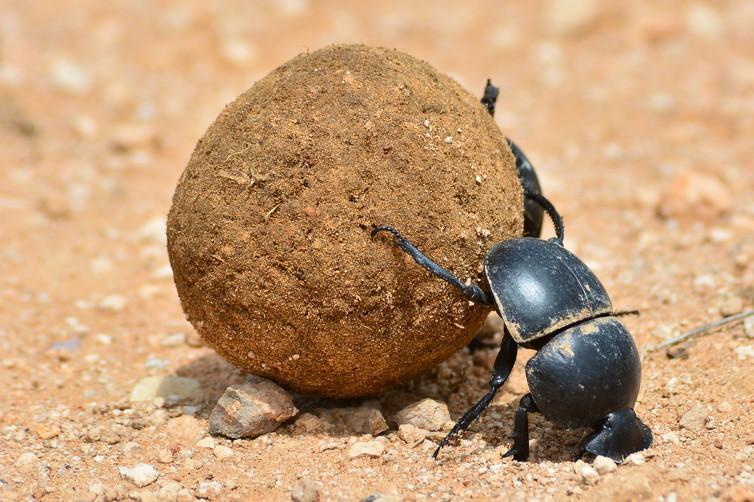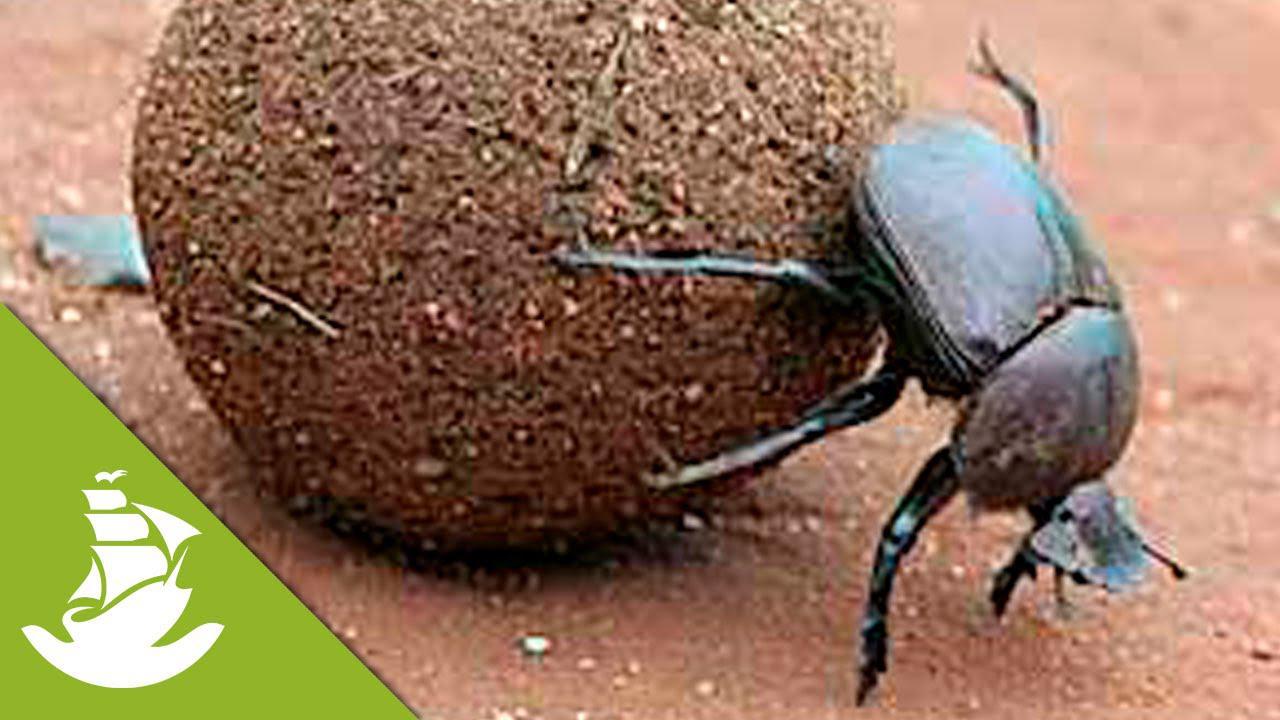The first image is the image on the left, the second image is the image on the right. Analyze the images presented: Is the assertion "Both images show beetles on dung balls with their bodies in the same general pose and location." valid? Answer yes or no. Yes. The first image is the image on the left, the second image is the image on the right. Given the left and right images, does the statement "There is a beetle that is not on a dung ball, in one image." hold true? Answer yes or no. No. The first image is the image on the left, the second image is the image on the right. Analyze the images presented: Is the assertion "A beetle is turned toward the left side of the photo in both images." valid? Answer yes or no. No. The first image is the image on the left, the second image is the image on the right. Examine the images to the left and right. Is the description "Two beetles are on a blue ball." accurate? Answer yes or no. No. The first image is the image on the left, the second image is the image on the right. For the images shown, is this caption "One image includes a beetle that is not in contact with a ball shape." true? Answer yes or no. No. 